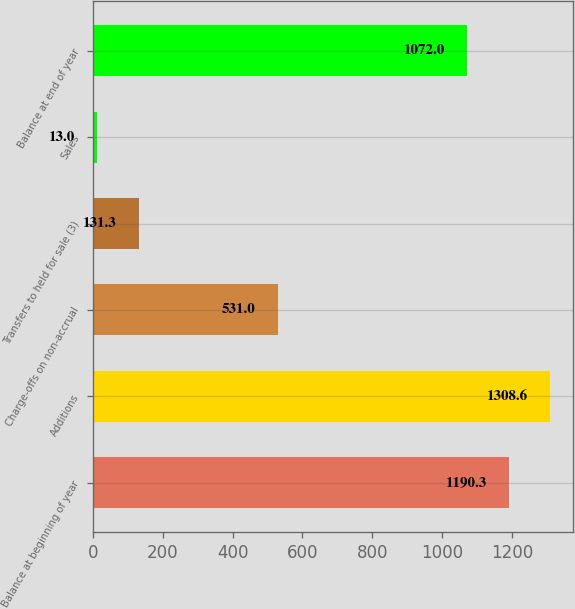<chart> <loc_0><loc_0><loc_500><loc_500><bar_chart><fcel>Balance at beginning of year<fcel>Additions<fcel>Charge-offs on non-accrual<fcel>Transfers to held for sale (3)<fcel>Sales<fcel>Balance at end of year<nl><fcel>1190.3<fcel>1308.6<fcel>531<fcel>131.3<fcel>13<fcel>1072<nl></chart> 